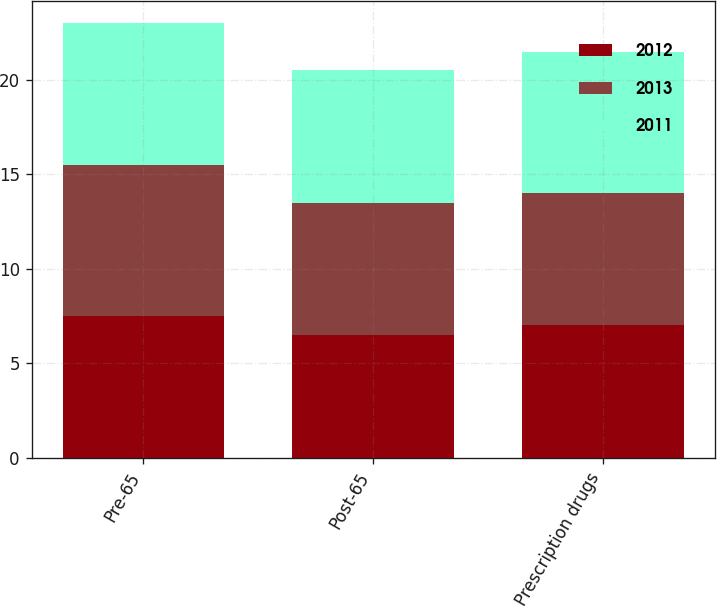Convert chart. <chart><loc_0><loc_0><loc_500><loc_500><stacked_bar_chart><ecel><fcel>Pre-65<fcel>Post-65<fcel>Prescription drugs<nl><fcel>2012<fcel>7.5<fcel>6.5<fcel>7<nl><fcel>2013<fcel>8<fcel>7<fcel>7<nl><fcel>2011<fcel>7.5<fcel>7<fcel>7.5<nl></chart> 